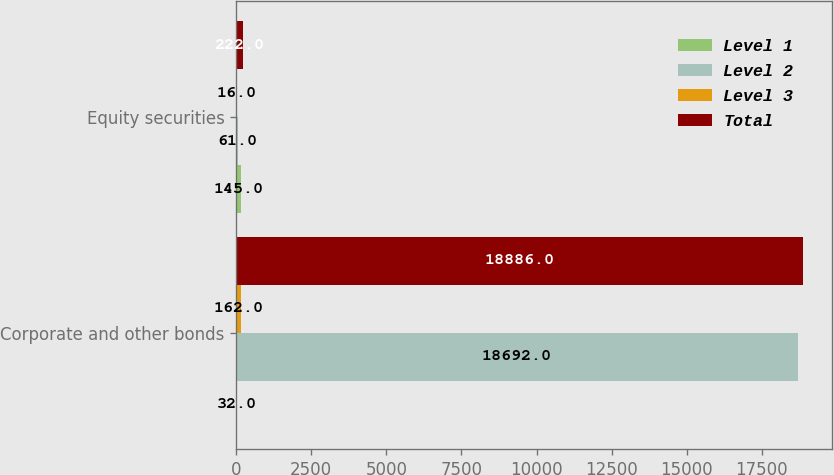Convert chart. <chart><loc_0><loc_0><loc_500><loc_500><stacked_bar_chart><ecel><fcel>Corporate and other bonds<fcel>Equity securities<nl><fcel>Level 1<fcel>32<fcel>145<nl><fcel>Level 2<fcel>18692<fcel>61<nl><fcel>Level 3<fcel>162<fcel>16<nl><fcel>Total<fcel>18886<fcel>222<nl></chart> 